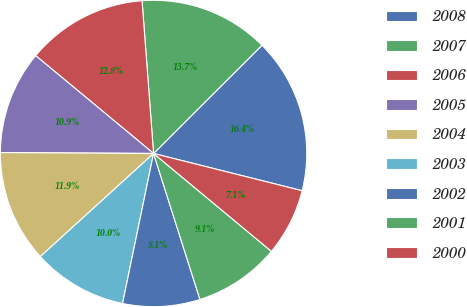Convert chart to OTSL. <chart><loc_0><loc_0><loc_500><loc_500><pie_chart><fcel>2008<fcel>2007<fcel>2006<fcel>2005<fcel>2004<fcel>2003<fcel>2002<fcel>2001<fcel>2000<nl><fcel>16.4%<fcel>13.71%<fcel>12.78%<fcel>10.93%<fcel>11.85%<fcel>10.0%<fcel>8.14%<fcel>9.07%<fcel>7.12%<nl></chart> 